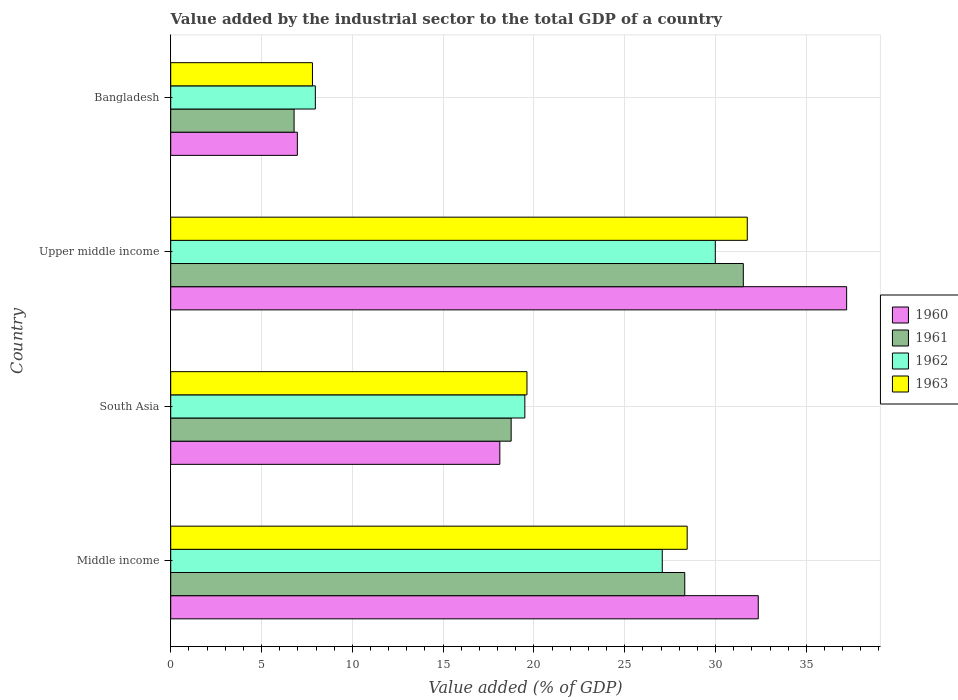Are the number of bars on each tick of the Y-axis equal?
Provide a short and direct response. Yes. How many bars are there on the 3rd tick from the top?
Your answer should be compact. 4. How many bars are there on the 3rd tick from the bottom?
Your response must be concise. 4. What is the label of the 3rd group of bars from the top?
Provide a short and direct response. South Asia. What is the value added by the industrial sector to the total GDP in 1961 in Middle income?
Offer a terse response. 28.31. Across all countries, what is the maximum value added by the industrial sector to the total GDP in 1961?
Offer a very short reply. 31.53. Across all countries, what is the minimum value added by the industrial sector to the total GDP in 1963?
Your answer should be very brief. 7.8. In which country was the value added by the industrial sector to the total GDP in 1961 maximum?
Your answer should be very brief. Upper middle income. In which country was the value added by the industrial sector to the total GDP in 1962 minimum?
Your answer should be very brief. Bangladesh. What is the total value added by the industrial sector to the total GDP in 1963 in the graph?
Offer a very short reply. 87.61. What is the difference between the value added by the industrial sector to the total GDP in 1962 in South Asia and that in Upper middle income?
Your response must be concise. -10.49. What is the difference between the value added by the industrial sector to the total GDP in 1962 in South Asia and the value added by the industrial sector to the total GDP in 1961 in Upper middle income?
Your answer should be very brief. -12.03. What is the average value added by the industrial sector to the total GDP in 1963 per country?
Your response must be concise. 21.9. What is the difference between the value added by the industrial sector to the total GDP in 1963 and value added by the industrial sector to the total GDP in 1961 in Middle income?
Offer a very short reply. 0.13. What is the ratio of the value added by the industrial sector to the total GDP in 1963 in Bangladesh to that in Upper middle income?
Offer a terse response. 0.25. Is the difference between the value added by the industrial sector to the total GDP in 1963 in Bangladesh and Upper middle income greater than the difference between the value added by the industrial sector to the total GDP in 1961 in Bangladesh and Upper middle income?
Make the answer very short. Yes. What is the difference between the highest and the second highest value added by the industrial sector to the total GDP in 1960?
Keep it short and to the point. 4.87. What is the difference between the highest and the lowest value added by the industrial sector to the total GDP in 1962?
Your answer should be very brief. 22.02. Is the sum of the value added by the industrial sector to the total GDP in 1963 in Bangladesh and Middle income greater than the maximum value added by the industrial sector to the total GDP in 1961 across all countries?
Give a very brief answer. Yes. What does the 2nd bar from the bottom in Middle income represents?
Your answer should be very brief. 1961. Is it the case that in every country, the sum of the value added by the industrial sector to the total GDP in 1961 and value added by the industrial sector to the total GDP in 1962 is greater than the value added by the industrial sector to the total GDP in 1960?
Your answer should be very brief. Yes. How many bars are there?
Your response must be concise. 16. Are all the bars in the graph horizontal?
Ensure brevity in your answer.  Yes. How many countries are there in the graph?
Your answer should be very brief. 4. Are the values on the major ticks of X-axis written in scientific E-notation?
Offer a terse response. No. Where does the legend appear in the graph?
Make the answer very short. Center right. What is the title of the graph?
Keep it short and to the point. Value added by the industrial sector to the total GDP of a country. What is the label or title of the X-axis?
Your answer should be very brief. Value added (% of GDP). What is the label or title of the Y-axis?
Provide a succinct answer. Country. What is the Value added (% of GDP) in 1960 in Middle income?
Provide a short and direct response. 32.35. What is the Value added (% of GDP) of 1961 in Middle income?
Ensure brevity in your answer.  28.31. What is the Value added (% of GDP) of 1962 in Middle income?
Provide a succinct answer. 27.07. What is the Value added (% of GDP) of 1963 in Middle income?
Your answer should be compact. 28.44. What is the Value added (% of GDP) in 1960 in South Asia?
Give a very brief answer. 18.12. What is the Value added (% of GDP) in 1961 in South Asia?
Ensure brevity in your answer.  18.75. What is the Value added (% of GDP) of 1962 in South Asia?
Ensure brevity in your answer.  19.5. What is the Value added (% of GDP) in 1963 in South Asia?
Provide a succinct answer. 19.62. What is the Value added (% of GDP) in 1960 in Upper middle income?
Provide a succinct answer. 37.22. What is the Value added (% of GDP) of 1961 in Upper middle income?
Your response must be concise. 31.53. What is the Value added (% of GDP) in 1962 in Upper middle income?
Your response must be concise. 29.99. What is the Value added (% of GDP) in 1963 in Upper middle income?
Your answer should be compact. 31.75. What is the Value added (% of GDP) of 1960 in Bangladesh?
Give a very brief answer. 6.97. What is the Value added (% of GDP) in 1961 in Bangladesh?
Give a very brief answer. 6.79. What is the Value added (% of GDP) of 1962 in Bangladesh?
Provide a short and direct response. 7.96. What is the Value added (% of GDP) in 1963 in Bangladesh?
Your answer should be very brief. 7.8. Across all countries, what is the maximum Value added (% of GDP) of 1960?
Offer a very short reply. 37.22. Across all countries, what is the maximum Value added (% of GDP) of 1961?
Make the answer very short. 31.53. Across all countries, what is the maximum Value added (% of GDP) in 1962?
Ensure brevity in your answer.  29.99. Across all countries, what is the maximum Value added (% of GDP) of 1963?
Your answer should be compact. 31.75. Across all countries, what is the minimum Value added (% of GDP) in 1960?
Your answer should be compact. 6.97. Across all countries, what is the minimum Value added (% of GDP) of 1961?
Ensure brevity in your answer.  6.79. Across all countries, what is the minimum Value added (% of GDP) of 1962?
Make the answer very short. 7.96. Across all countries, what is the minimum Value added (% of GDP) in 1963?
Keep it short and to the point. 7.8. What is the total Value added (% of GDP) in 1960 in the graph?
Provide a short and direct response. 94.67. What is the total Value added (% of GDP) in 1961 in the graph?
Offer a terse response. 85.38. What is the total Value added (% of GDP) of 1962 in the graph?
Offer a terse response. 84.52. What is the total Value added (% of GDP) of 1963 in the graph?
Offer a very short reply. 87.61. What is the difference between the Value added (% of GDP) of 1960 in Middle income and that in South Asia?
Provide a succinct answer. 14.23. What is the difference between the Value added (% of GDP) of 1961 in Middle income and that in South Asia?
Your answer should be compact. 9.56. What is the difference between the Value added (% of GDP) in 1962 in Middle income and that in South Asia?
Your response must be concise. 7.57. What is the difference between the Value added (% of GDP) in 1963 in Middle income and that in South Asia?
Keep it short and to the point. 8.82. What is the difference between the Value added (% of GDP) in 1960 in Middle income and that in Upper middle income?
Ensure brevity in your answer.  -4.87. What is the difference between the Value added (% of GDP) in 1961 in Middle income and that in Upper middle income?
Keep it short and to the point. -3.23. What is the difference between the Value added (% of GDP) of 1962 in Middle income and that in Upper middle income?
Your answer should be compact. -2.92. What is the difference between the Value added (% of GDP) of 1963 in Middle income and that in Upper middle income?
Give a very brief answer. -3.31. What is the difference between the Value added (% of GDP) in 1960 in Middle income and that in Bangladesh?
Give a very brief answer. 25.38. What is the difference between the Value added (% of GDP) in 1961 in Middle income and that in Bangladesh?
Ensure brevity in your answer.  21.51. What is the difference between the Value added (% of GDP) of 1962 in Middle income and that in Bangladesh?
Your answer should be compact. 19.1. What is the difference between the Value added (% of GDP) of 1963 in Middle income and that in Bangladesh?
Ensure brevity in your answer.  20.63. What is the difference between the Value added (% of GDP) in 1960 in South Asia and that in Upper middle income?
Offer a very short reply. -19.1. What is the difference between the Value added (% of GDP) of 1961 in South Asia and that in Upper middle income?
Offer a very short reply. -12.78. What is the difference between the Value added (% of GDP) of 1962 in South Asia and that in Upper middle income?
Your response must be concise. -10.49. What is the difference between the Value added (% of GDP) in 1963 in South Asia and that in Upper middle income?
Your answer should be compact. -12.13. What is the difference between the Value added (% of GDP) of 1960 in South Asia and that in Bangladesh?
Provide a short and direct response. 11.15. What is the difference between the Value added (% of GDP) in 1961 in South Asia and that in Bangladesh?
Your answer should be very brief. 11.95. What is the difference between the Value added (% of GDP) of 1962 in South Asia and that in Bangladesh?
Offer a very short reply. 11.54. What is the difference between the Value added (% of GDP) of 1963 in South Asia and that in Bangladesh?
Make the answer very short. 11.81. What is the difference between the Value added (% of GDP) in 1960 in Upper middle income and that in Bangladesh?
Ensure brevity in your answer.  30.25. What is the difference between the Value added (% of GDP) of 1961 in Upper middle income and that in Bangladesh?
Offer a terse response. 24.74. What is the difference between the Value added (% of GDP) in 1962 in Upper middle income and that in Bangladesh?
Your answer should be very brief. 22.02. What is the difference between the Value added (% of GDP) in 1963 in Upper middle income and that in Bangladesh?
Your answer should be compact. 23.94. What is the difference between the Value added (% of GDP) of 1960 in Middle income and the Value added (% of GDP) of 1961 in South Asia?
Keep it short and to the point. 13.61. What is the difference between the Value added (% of GDP) in 1960 in Middle income and the Value added (% of GDP) in 1962 in South Asia?
Your answer should be very brief. 12.85. What is the difference between the Value added (% of GDP) in 1960 in Middle income and the Value added (% of GDP) in 1963 in South Asia?
Offer a terse response. 12.74. What is the difference between the Value added (% of GDP) in 1961 in Middle income and the Value added (% of GDP) in 1962 in South Asia?
Your response must be concise. 8.8. What is the difference between the Value added (% of GDP) in 1961 in Middle income and the Value added (% of GDP) in 1963 in South Asia?
Offer a terse response. 8.69. What is the difference between the Value added (% of GDP) of 1962 in Middle income and the Value added (% of GDP) of 1963 in South Asia?
Offer a very short reply. 7.45. What is the difference between the Value added (% of GDP) of 1960 in Middle income and the Value added (% of GDP) of 1961 in Upper middle income?
Ensure brevity in your answer.  0.82. What is the difference between the Value added (% of GDP) in 1960 in Middle income and the Value added (% of GDP) in 1962 in Upper middle income?
Offer a terse response. 2.37. What is the difference between the Value added (% of GDP) in 1960 in Middle income and the Value added (% of GDP) in 1963 in Upper middle income?
Your response must be concise. 0.61. What is the difference between the Value added (% of GDP) of 1961 in Middle income and the Value added (% of GDP) of 1962 in Upper middle income?
Offer a terse response. -1.68. What is the difference between the Value added (% of GDP) of 1961 in Middle income and the Value added (% of GDP) of 1963 in Upper middle income?
Offer a terse response. -3.44. What is the difference between the Value added (% of GDP) of 1962 in Middle income and the Value added (% of GDP) of 1963 in Upper middle income?
Offer a terse response. -4.68. What is the difference between the Value added (% of GDP) of 1960 in Middle income and the Value added (% of GDP) of 1961 in Bangladesh?
Make the answer very short. 25.56. What is the difference between the Value added (% of GDP) in 1960 in Middle income and the Value added (% of GDP) in 1962 in Bangladesh?
Provide a succinct answer. 24.39. What is the difference between the Value added (% of GDP) of 1960 in Middle income and the Value added (% of GDP) of 1963 in Bangladesh?
Keep it short and to the point. 24.55. What is the difference between the Value added (% of GDP) of 1961 in Middle income and the Value added (% of GDP) of 1962 in Bangladesh?
Make the answer very short. 20.34. What is the difference between the Value added (% of GDP) of 1961 in Middle income and the Value added (% of GDP) of 1963 in Bangladesh?
Provide a succinct answer. 20.5. What is the difference between the Value added (% of GDP) in 1962 in Middle income and the Value added (% of GDP) in 1963 in Bangladesh?
Your answer should be very brief. 19.26. What is the difference between the Value added (% of GDP) in 1960 in South Asia and the Value added (% of GDP) in 1961 in Upper middle income?
Provide a short and direct response. -13.41. What is the difference between the Value added (% of GDP) in 1960 in South Asia and the Value added (% of GDP) in 1962 in Upper middle income?
Make the answer very short. -11.86. What is the difference between the Value added (% of GDP) in 1960 in South Asia and the Value added (% of GDP) in 1963 in Upper middle income?
Your answer should be very brief. -13.63. What is the difference between the Value added (% of GDP) in 1961 in South Asia and the Value added (% of GDP) in 1962 in Upper middle income?
Ensure brevity in your answer.  -11.24. What is the difference between the Value added (% of GDP) of 1961 in South Asia and the Value added (% of GDP) of 1963 in Upper middle income?
Provide a short and direct response. -13. What is the difference between the Value added (% of GDP) in 1962 in South Asia and the Value added (% of GDP) in 1963 in Upper middle income?
Provide a succinct answer. -12.25. What is the difference between the Value added (% of GDP) of 1960 in South Asia and the Value added (% of GDP) of 1961 in Bangladesh?
Ensure brevity in your answer.  11.33. What is the difference between the Value added (% of GDP) in 1960 in South Asia and the Value added (% of GDP) in 1962 in Bangladesh?
Your response must be concise. 10.16. What is the difference between the Value added (% of GDP) in 1960 in South Asia and the Value added (% of GDP) in 1963 in Bangladesh?
Ensure brevity in your answer.  10.32. What is the difference between the Value added (% of GDP) in 1961 in South Asia and the Value added (% of GDP) in 1962 in Bangladesh?
Provide a succinct answer. 10.78. What is the difference between the Value added (% of GDP) of 1961 in South Asia and the Value added (% of GDP) of 1963 in Bangladesh?
Your response must be concise. 10.94. What is the difference between the Value added (% of GDP) of 1962 in South Asia and the Value added (% of GDP) of 1963 in Bangladesh?
Give a very brief answer. 11.7. What is the difference between the Value added (% of GDP) of 1960 in Upper middle income and the Value added (% of GDP) of 1961 in Bangladesh?
Offer a very short reply. 30.43. What is the difference between the Value added (% of GDP) in 1960 in Upper middle income and the Value added (% of GDP) in 1962 in Bangladesh?
Ensure brevity in your answer.  29.26. What is the difference between the Value added (% of GDP) in 1960 in Upper middle income and the Value added (% of GDP) in 1963 in Bangladesh?
Give a very brief answer. 29.42. What is the difference between the Value added (% of GDP) in 1961 in Upper middle income and the Value added (% of GDP) in 1962 in Bangladesh?
Make the answer very short. 23.57. What is the difference between the Value added (% of GDP) of 1961 in Upper middle income and the Value added (% of GDP) of 1963 in Bangladesh?
Your response must be concise. 23.73. What is the difference between the Value added (% of GDP) of 1962 in Upper middle income and the Value added (% of GDP) of 1963 in Bangladesh?
Give a very brief answer. 22.18. What is the average Value added (% of GDP) in 1960 per country?
Ensure brevity in your answer.  23.67. What is the average Value added (% of GDP) of 1961 per country?
Provide a short and direct response. 21.34. What is the average Value added (% of GDP) in 1962 per country?
Offer a terse response. 21.13. What is the average Value added (% of GDP) of 1963 per country?
Provide a succinct answer. 21.9. What is the difference between the Value added (% of GDP) of 1960 and Value added (% of GDP) of 1961 in Middle income?
Offer a terse response. 4.05. What is the difference between the Value added (% of GDP) in 1960 and Value added (% of GDP) in 1962 in Middle income?
Ensure brevity in your answer.  5.29. What is the difference between the Value added (% of GDP) of 1960 and Value added (% of GDP) of 1963 in Middle income?
Keep it short and to the point. 3.92. What is the difference between the Value added (% of GDP) in 1961 and Value added (% of GDP) in 1962 in Middle income?
Offer a terse response. 1.24. What is the difference between the Value added (% of GDP) of 1961 and Value added (% of GDP) of 1963 in Middle income?
Provide a succinct answer. -0.13. What is the difference between the Value added (% of GDP) of 1962 and Value added (% of GDP) of 1963 in Middle income?
Offer a very short reply. -1.37. What is the difference between the Value added (% of GDP) of 1960 and Value added (% of GDP) of 1961 in South Asia?
Offer a very short reply. -0.62. What is the difference between the Value added (% of GDP) in 1960 and Value added (% of GDP) in 1962 in South Asia?
Provide a short and direct response. -1.38. What is the difference between the Value added (% of GDP) of 1960 and Value added (% of GDP) of 1963 in South Asia?
Provide a short and direct response. -1.49. What is the difference between the Value added (% of GDP) in 1961 and Value added (% of GDP) in 1962 in South Asia?
Your answer should be compact. -0.75. What is the difference between the Value added (% of GDP) in 1961 and Value added (% of GDP) in 1963 in South Asia?
Provide a short and direct response. -0.87. What is the difference between the Value added (% of GDP) in 1962 and Value added (% of GDP) in 1963 in South Asia?
Offer a terse response. -0.12. What is the difference between the Value added (% of GDP) in 1960 and Value added (% of GDP) in 1961 in Upper middle income?
Keep it short and to the point. 5.69. What is the difference between the Value added (% of GDP) of 1960 and Value added (% of GDP) of 1962 in Upper middle income?
Provide a succinct answer. 7.23. What is the difference between the Value added (% of GDP) of 1960 and Value added (% of GDP) of 1963 in Upper middle income?
Keep it short and to the point. 5.47. What is the difference between the Value added (% of GDP) in 1961 and Value added (% of GDP) in 1962 in Upper middle income?
Provide a short and direct response. 1.54. What is the difference between the Value added (% of GDP) of 1961 and Value added (% of GDP) of 1963 in Upper middle income?
Provide a succinct answer. -0.22. What is the difference between the Value added (% of GDP) of 1962 and Value added (% of GDP) of 1963 in Upper middle income?
Offer a very short reply. -1.76. What is the difference between the Value added (% of GDP) in 1960 and Value added (% of GDP) in 1961 in Bangladesh?
Provide a short and direct response. 0.18. What is the difference between the Value added (% of GDP) of 1960 and Value added (% of GDP) of 1962 in Bangladesh?
Offer a very short reply. -0.99. What is the difference between the Value added (% of GDP) in 1960 and Value added (% of GDP) in 1963 in Bangladesh?
Offer a very short reply. -0.83. What is the difference between the Value added (% of GDP) in 1961 and Value added (% of GDP) in 1962 in Bangladesh?
Provide a short and direct response. -1.17. What is the difference between the Value added (% of GDP) in 1961 and Value added (% of GDP) in 1963 in Bangladesh?
Offer a very short reply. -1.01. What is the difference between the Value added (% of GDP) of 1962 and Value added (% of GDP) of 1963 in Bangladesh?
Offer a terse response. 0.16. What is the ratio of the Value added (% of GDP) in 1960 in Middle income to that in South Asia?
Make the answer very short. 1.79. What is the ratio of the Value added (% of GDP) in 1961 in Middle income to that in South Asia?
Your answer should be very brief. 1.51. What is the ratio of the Value added (% of GDP) of 1962 in Middle income to that in South Asia?
Provide a succinct answer. 1.39. What is the ratio of the Value added (% of GDP) of 1963 in Middle income to that in South Asia?
Your answer should be very brief. 1.45. What is the ratio of the Value added (% of GDP) in 1960 in Middle income to that in Upper middle income?
Make the answer very short. 0.87. What is the ratio of the Value added (% of GDP) in 1961 in Middle income to that in Upper middle income?
Provide a succinct answer. 0.9. What is the ratio of the Value added (% of GDP) in 1962 in Middle income to that in Upper middle income?
Keep it short and to the point. 0.9. What is the ratio of the Value added (% of GDP) of 1963 in Middle income to that in Upper middle income?
Keep it short and to the point. 0.9. What is the ratio of the Value added (% of GDP) of 1960 in Middle income to that in Bangladesh?
Your answer should be very brief. 4.64. What is the ratio of the Value added (% of GDP) in 1961 in Middle income to that in Bangladesh?
Your answer should be very brief. 4.17. What is the ratio of the Value added (% of GDP) in 1962 in Middle income to that in Bangladesh?
Keep it short and to the point. 3.4. What is the ratio of the Value added (% of GDP) in 1963 in Middle income to that in Bangladesh?
Give a very brief answer. 3.64. What is the ratio of the Value added (% of GDP) of 1960 in South Asia to that in Upper middle income?
Your answer should be very brief. 0.49. What is the ratio of the Value added (% of GDP) in 1961 in South Asia to that in Upper middle income?
Your answer should be very brief. 0.59. What is the ratio of the Value added (% of GDP) of 1962 in South Asia to that in Upper middle income?
Keep it short and to the point. 0.65. What is the ratio of the Value added (% of GDP) in 1963 in South Asia to that in Upper middle income?
Ensure brevity in your answer.  0.62. What is the ratio of the Value added (% of GDP) in 1960 in South Asia to that in Bangladesh?
Offer a very short reply. 2.6. What is the ratio of the Value added (% of GDP) of 1961 in South Asia to that in Bangladesh?
Your answer should be compact. 2.76. What is the ratio of the Value added (% of GDP) of 1962 in South Asia to that in Bangladesh?
Provide a succinct answer. 2.45. What is the ratio of the Value added (% of GDP) in 1963 in South Asia to that in Bangladesh?
Offer a very short reply. 2.51. What is the ratio of the Value added (% of GDP) in 1960 in Upper middle income to that in Bangladesh?
Offer a terse response. 5.34. What is the ratio of the Value added (% of GDP) in 1961 in Upper middle income to that in Bangladesh?
Provide a succinct answer. 4.64. What is the ratio of the Value added (% of GDP) in 1962 in Upper middle income to that in Bangladesh?
Provide a succinct answer. 3.77. What is the ratio of the Value added (% of GDP) of 1963 in Upper middle income to that in Bangladesh?
Provide a succinct answer. 4.07. What is the difference between the highest and the second highest Value added (% of GDP) in 1960?
Provide a succinct answer. 4.87. What is the difference between the highest and the second highest Value added (% of GDP) in 1961?
Keep it short and to the point. 3.23. What is the difference between the highest and the second highest Value added (% of GDP) of 1962?
Offer a very short reply. 2.92. What is the difference between the highest and the second highest Value added (% of GDP) in 1963?
Provide a succinct answer. 3.31. What is the difference between the highest and the lowest Value added (% of GDP) in 1960?
Provide a succinct answer. 30.25. What is the difference between the highest and the lowest Value added (% of GDP) of 1961?
Make the answer very short. 24.74. What is the difference between the highest and the lowest Value added (% of GDP) of 1962?
Provide a short and direct response. 22.02. What is the difference between the highest and the lowest Value added (% of GDP) of 1963?
Your answer should be compact. 23.94. 